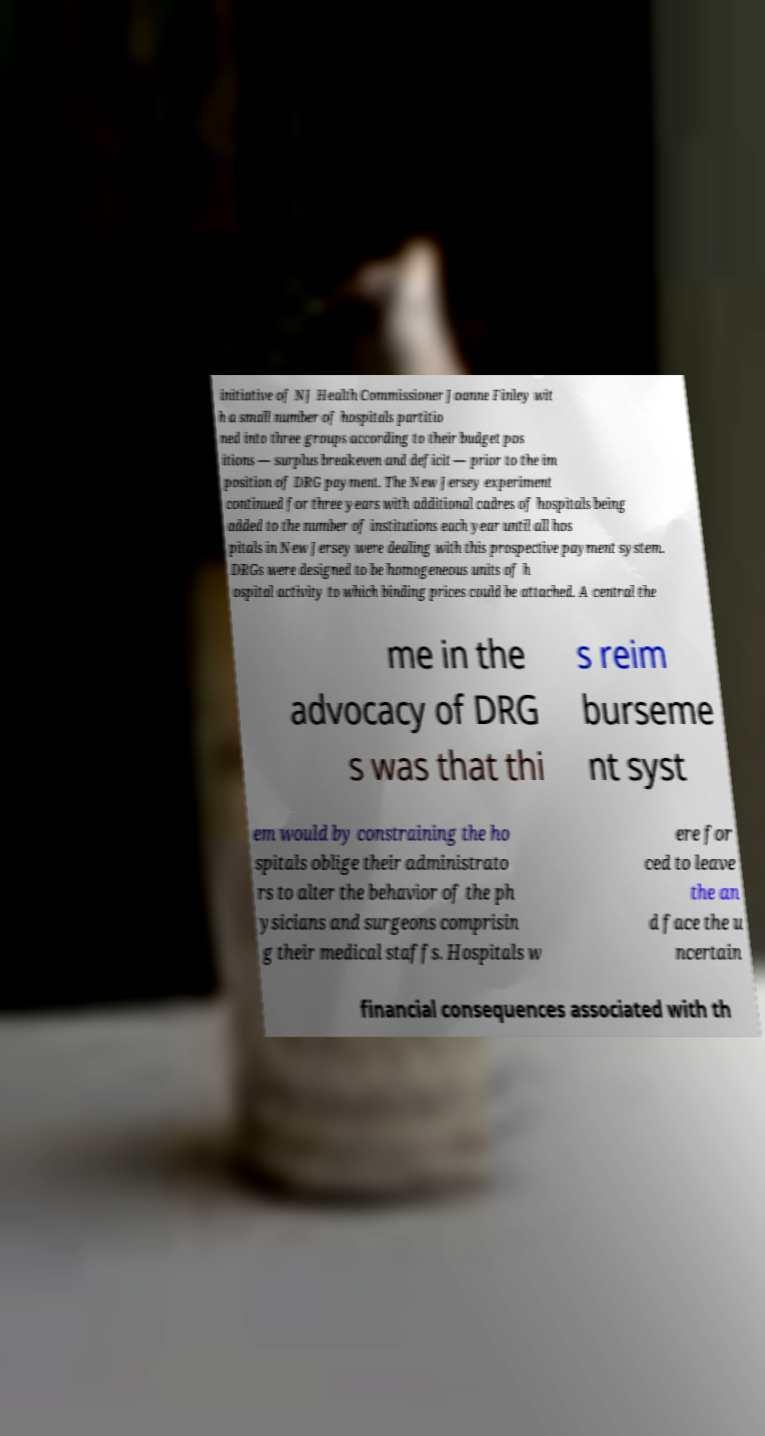Could you assist in decoding the text presented in this image and type it out clearly? initiative of NJ Health Commissioner Joanne Finley wit h a small number of hospitals partitio ned into three groups according to their budget pos itions — surplus breakeven and deficit — prior to the im position of DRG payment. The New Jersey experiment continued for three years with additional cadres of hospitals being added to the number of institutions each year until all hos pitals in New Jersey were dealing with this prospective payment system. DRGs were designed to be homogeneous units of h ospital activity to which binding prices could be attached. A central the me in the advocacy of DRG s was that thi s reim burseme nt syst em would by constraining the ho spitals oblige their administrato rs to alter the behavior of the ph ysicians and surgeons comprisin g their medical staffs. Hospitals w ere for ced to leave the an d face the u ncertain financial consequences associated with th 